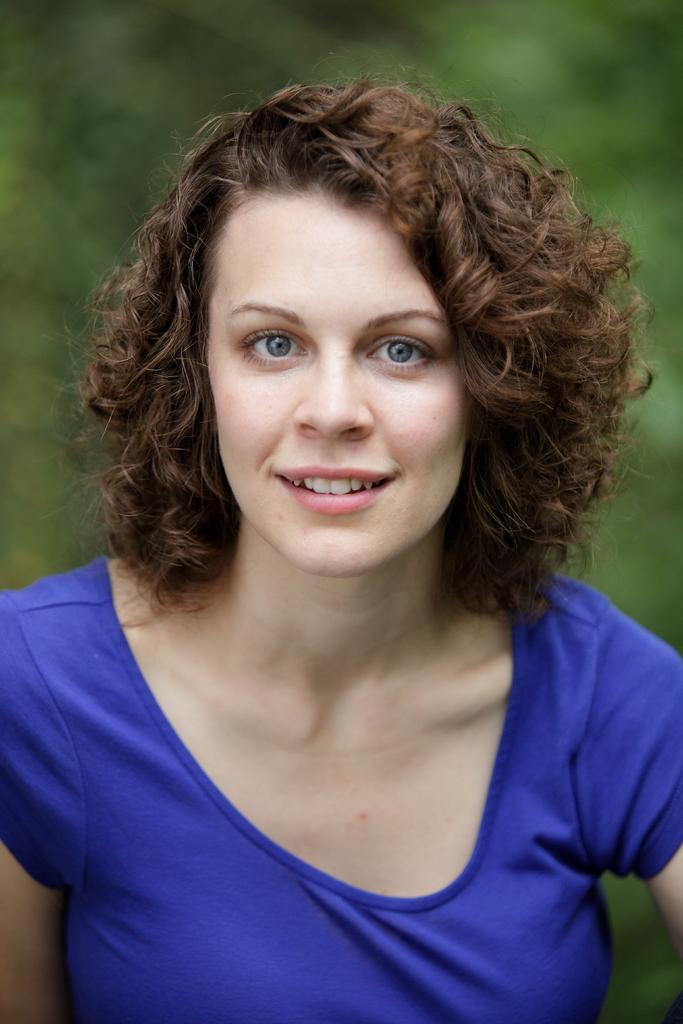Who is the main subject in the image? There is a lady in the image. What can be observed about the background of the image? The background of the image is blurred. What type of hydrant can be seen in the image? There is no hydrant present in the image. What thrilling activity is the lady participating in the image? The image does not depict any specific activity, so it cannot be determined if it is thrilling or not. Where is the drawer located in the image? There is no drawer present in the image. 